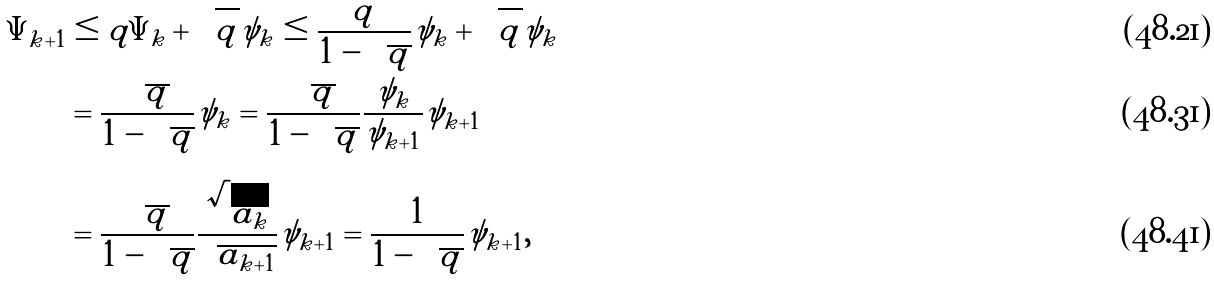<formula> <loc_0><loc_0><loc_500><loc_500>\Psi _ { k + 1 } & \leq q \Psi _ { k } + \sqrt { q } \psi _ { k } \leq \frac { q } { 1 - \sqrt { q } } \psi _ { k } + \sqrt { q } \psi _ { k } \\ & = \frac { \sqrt { q } } { 1 - \sqrt { q } } \psi _ { k } = \frac { \sqrt { q } } { 1 - \sqrt { q } } \frac { \psi _ { k } } { \psi _ { k + 1 } } \psi _ { k + 1 } \\ & = \frac { \sqrt { q } } { 1 - \sqrt { q } } \frac { \sqrt { a _ { k } } } { \sqrt { a _ { k + 1 } } } \psi _ { k + 1 } = \frac { 1 } { 1 - \sqrt { q } } \psi _ { k + 1 } ,</formula> 